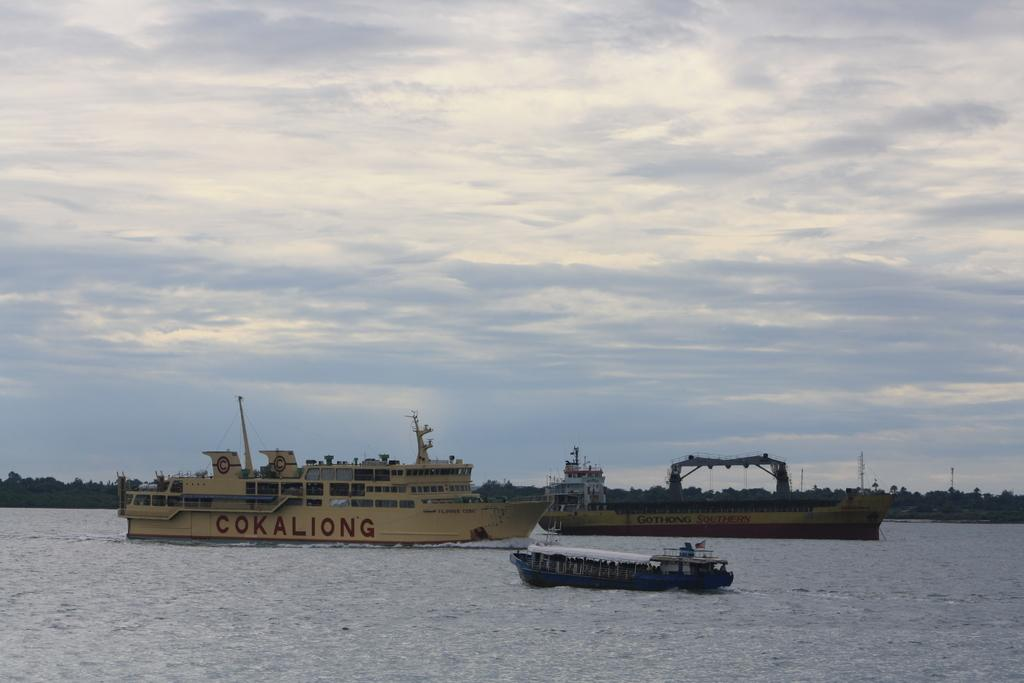What is the primary element visible in the image? There is water in the image. What can be seen floating on the water? There are ships in the image. What type of vegetation is visible in the background of the image? There are many trees in the background of the image. What type of structure is present in the image? There is a building in the image. What part of the natural environment is visible in the image? The sky is visible in the image. How many trains are visible in the image? There are no trains present in the image. What type of laborer can be seen working on the building in the image? There is no laborer visible in the image; only the building itself is present. 